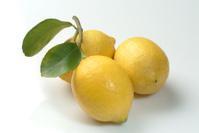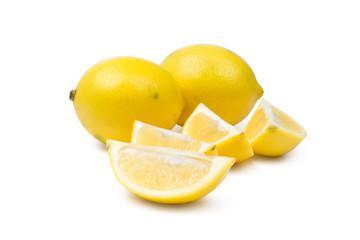The first image is the image on the left, the second image is the image on the right. Evaluate the accuracy of this statement regarding the images: "In at least one image, there are three yellow lemons with at single stock of leaves next to the lemon on the left side.". Is it true? Answer yes or no. Yes. The first image is the image on the left, the second image is the image on the right. For the images shown, is this caption "Exactly one of the images of lemons includes leaves." true? Answer yes or no. Yes. 